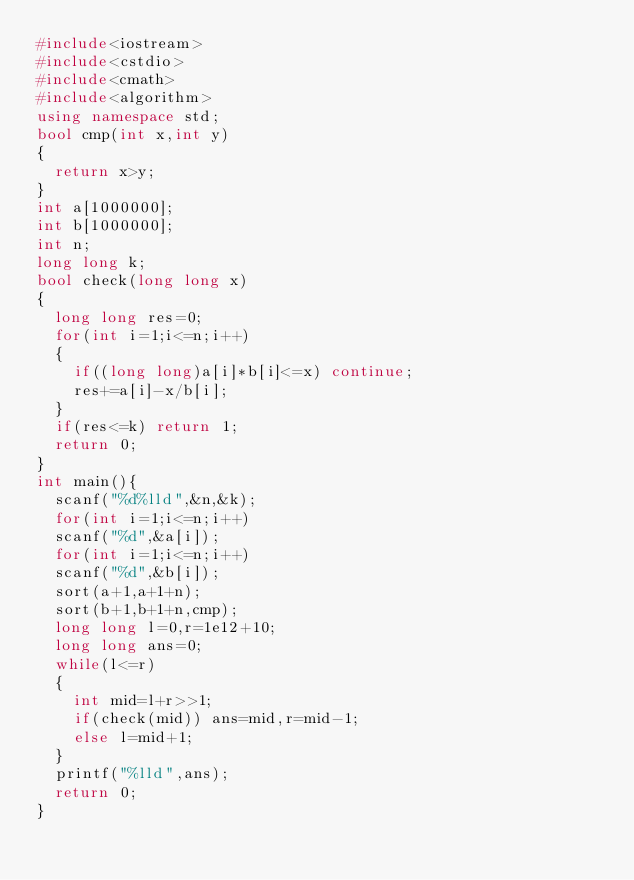<code> <loc_0><loc_0><loc_500><loc_500><_C++_>#include<iostream>
#include<cstdio>
#include<cmath>
#include<algorithm> 
using namespace std;
bool cmp(int x,int y)
{
	return x>y;
}
int a[1000000];
int b[1000000];
int n;
long long k;
bool check(long long x)
{
	long long res=0;
	for(int i=1;i<=n;i++)
	{
		if((long long)a[i]*b[i]<=x) continue;
		res+=a[i]-x/b[i];
	}
	if(res<=k) return 1;
	return 0;
}
int main(){
	scanf("%d%lld",&n,&k);
	for(int i=1;i<=n;i++)
	scanf("%d",&a[i]);
	for(int i=1;i<=n;i++)
	scanf("%d",&b[i]);
	sort(a+1,a+1+n);
	sort(b+1,b+1+n,cmp);
	long long l=0,r=1e12+10;
	long long ans=0;
	while(l<=r)
	{
		int mid=l+r>>1;
		if(check(mid)) ans=mid,r=mid-1;
		else l=mid+1;
	}
	printf("%lld",ans);
	return 0;
}</code> 